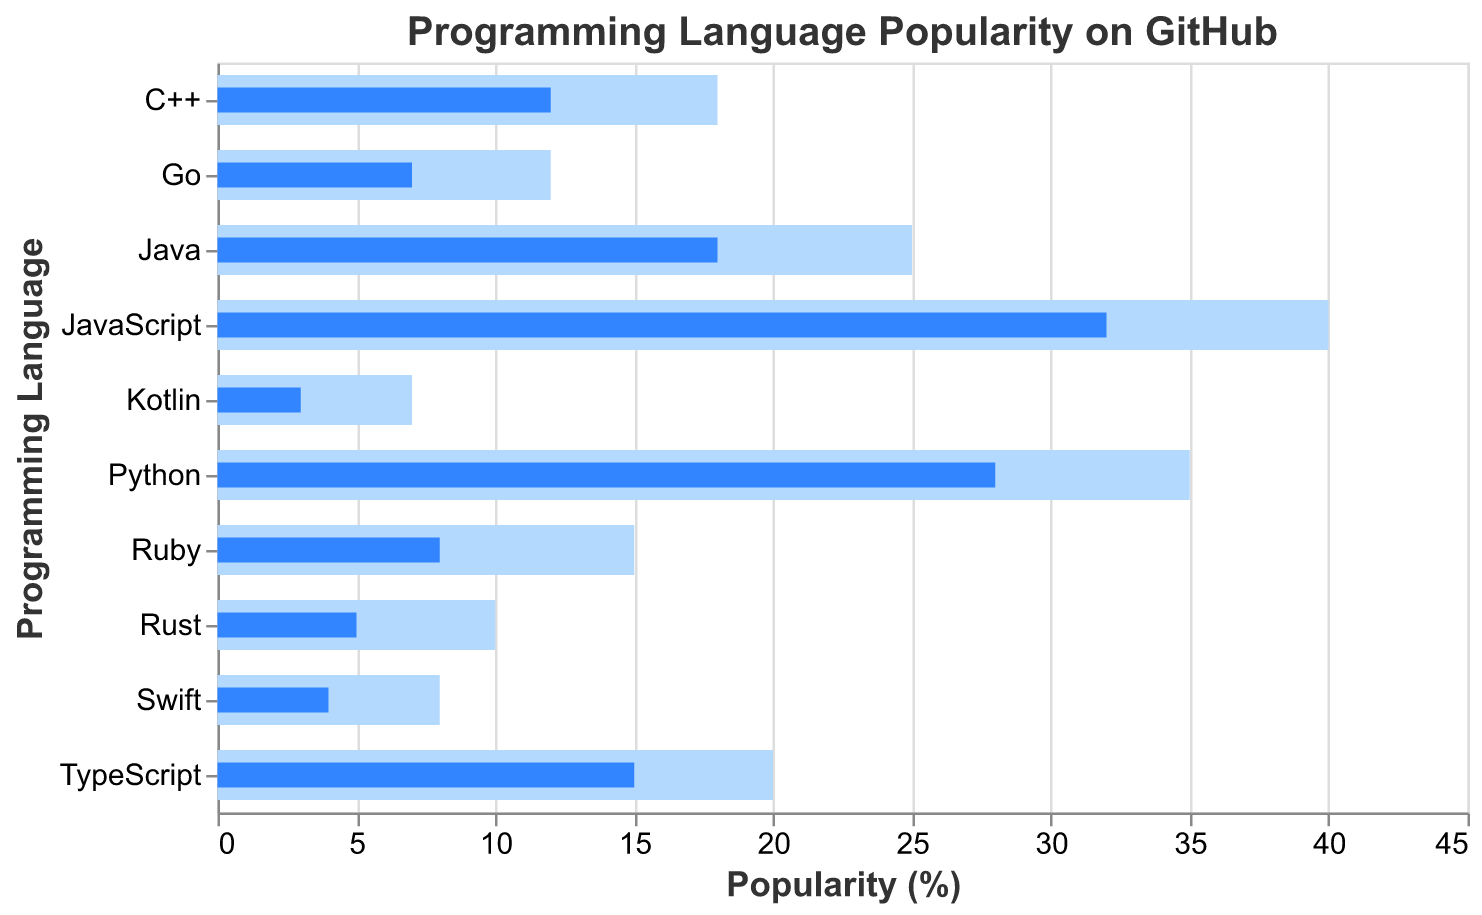What is the title of the chart? The title of the chart is usually placed at the top of the figure. In this case, the title is "Programming Language Popularity on GitHub."
Answer: Programming Language Popularity on GitHub How many programming languages are displayed in the chart? By counting the data points or categories along the y-axis, we can see that there are 10 programming languages shown in the chart.
Answer: 10 Which programming language has the highest current usage on GitHub? To determine this, we look at the bars and find the one with the highest value for "Current Usage." JavaScript has the highest current usage at 32%.
Answer: JavaScript What is the goal usage for Python? To find the goal usage for Python, look at the value associated with the light blue bar for Python. The goal usage is 35%.
Answer: 35% What's the difference between the goal and current usage for Kotlin? The goal usage for Kotlin is 7%, while the current usage is 3%. Subtracting the current usage from the goal usage gives the difference: 7% - 3% = 4%.
Answer: 4% List the languages whose current usage is above 20%. By inspecting the chart, the languages with current usage above 20% are JavaScript (32%) and Python (28%).
Answer: JavaScript, Python Which language has the largest gap between its current usage and its goal usage? The gaps can be calculated by subtracting the current usage from the goal usage for each language. The largest gap is for Ruby (15% - 8% = 7%).
Answer: Ruby Is the current usage of C++ greater than or equal to its goal usage? By comparing the current usage (12%) to the goal usage (18%) of C++, we see that the current usage is less than its goal usage.
Answer: No What’s the sum of the current usage of the three least popular languages? The three least popular languages based on current usage are Kotlin (3%), Swift (4%), and Rust (5%). Summing up these values: 3% + 4% + 5% = 12%.
Answer: 12% By how much does JavaScript's current usage exceed Java's current usage? JavaScript's current usage is 32%, and Java's current usage is 18%. Subtracting Java's usage from JavaScript's usage gives: 32% - 18% = 14%.
Answer: 14% 